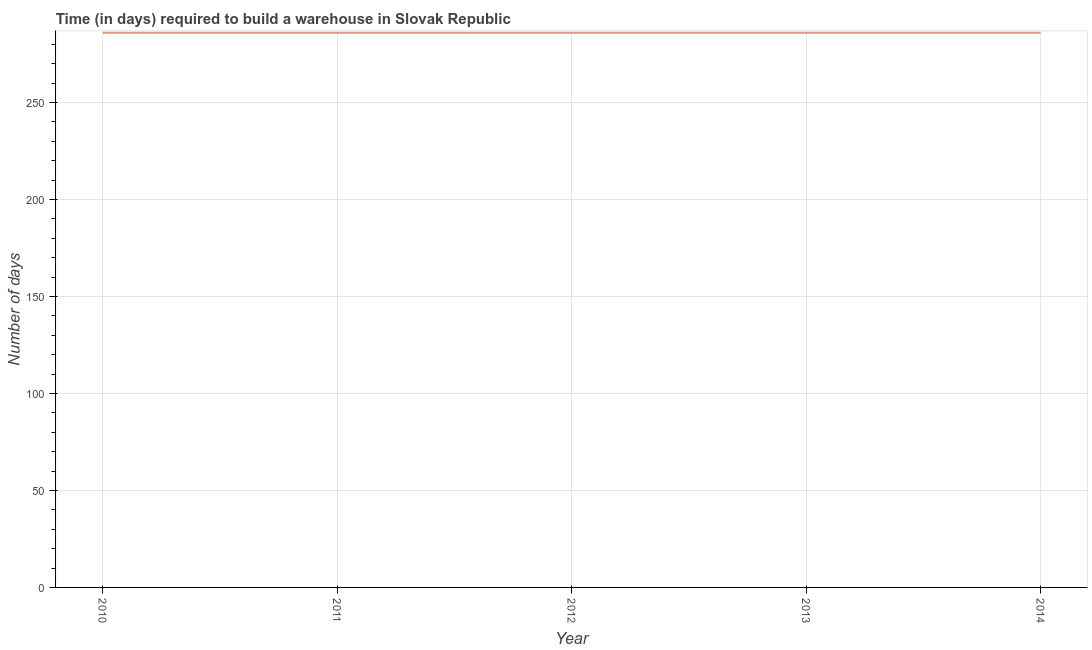What is the time required to build a warehouse in 2012?
Give a very brief answer. 286. Across all years, what is the maximum time required to build a warehouse?
Give a very brief answer. 286. Across all years, what is the minimum time required to build a warehouse?
Provide a succinct answer. 286. What is the sum of the time required to build a warehouse?
Offer a terse response. 1430. What is the difference between the time required to build a warehouse in 2011 and 2012?
Your answer should be compact. 0. What is the average time required to build a warehouse per year?
Your answer should be compact. 286. What is the median time required to build a warehouse?
Your response must be concise. 286. Do a majority of the years between 2011 and 2012 (inclusive) have time required to build a warehouse greater than 210 days?
Provide a succinct answer. Yes. Does the graph contain any zero values?
Provide a short and direct response. No. Does the graph contain grids?
Provide a succinct answer. Yes. What is the title of the graph?
Offer a terse response. Time (in days) required to build a warehouse in Slovak Republic. What is the label or title of the Y-axis?
Provide a short and direct response. Number of days. What is the Number of days of 2010?
Keep it short and to the point. 286. What is the Number of days in 2011?
Your answer should be compact. 286. What is the Number of days of 2012?
Your response must be concise. 286. What is the Number of days of 2013?
Make the answer very short. 286. What is the Number of days in 2014?
Keep it short and to the point. 286. What is the difference between the Number of days in 2010 and 2011?
Make the answer very short. 0. What is the difference between the Number of days in 2010 and 2013?
Ensure brevity in your answer.  0. What is the difference between the Number of days in 2010 and 2014?
Provide a succinct answer. 0. What is the difference between the Number of days in 2011 and 2012?
Offer a terse response. 0. What is the difference between the Number of days in 2011 and 2014?
Your answer should be very brief. 0. What is the difference between the Number of days in 2012 and 2013?
Provide a short and direct response. 0. What is the difference between the Number of days in 2013 and 2014?
Your response must be concise. 0. What is the ratio of the Number of days in 2010 to that in 2012?
Provide a succinct answer. 1. What is the ratio of the Number of days in 2010 to that in 2014?
Offer a terse response. 1. What is the ratio of the Number of days in 2011 to that in 2014?
Provide a succinct answer. 1. What is the ratio of the Number of days in 2012 to that in 2014?
Make the answer very short. 1. What is the ratio of the Number of days in 2013 to that in 2014?
Offer a terse response. 1. 